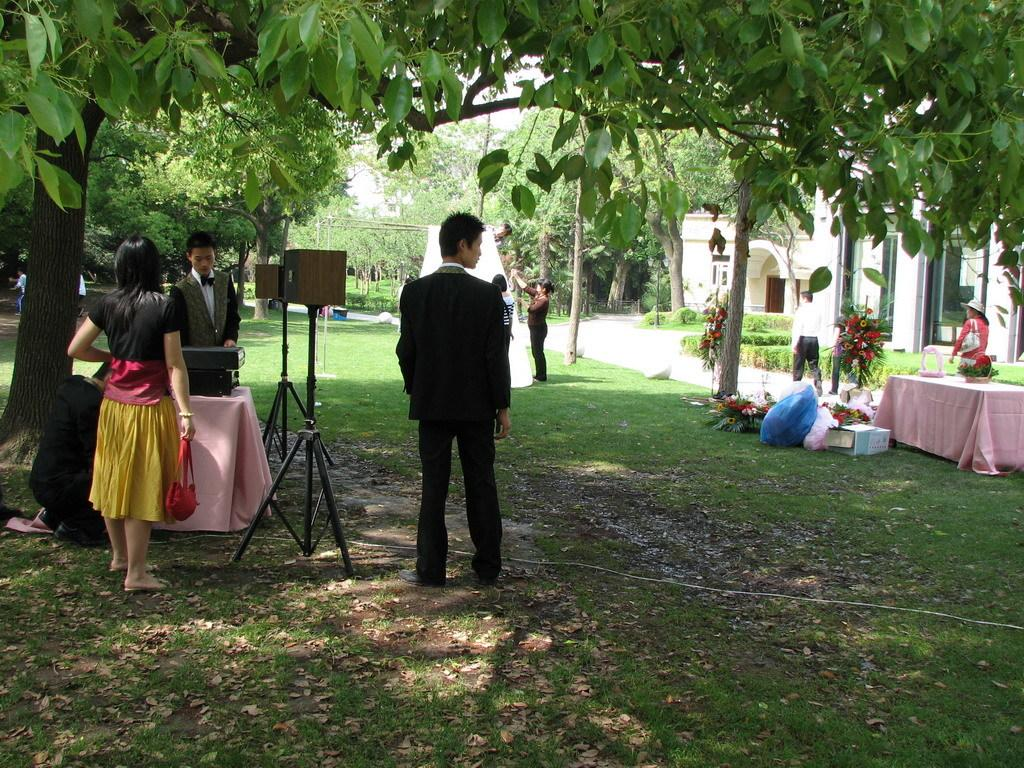Who or what is present in the image? There are people in the image. What object can be seen on the table in the image? There is a flower pot on the table. What type of vegetation is visible in the image? There are trees visible in the image. What can be seen in the background of the image? There is a building in the background of the image. How many deer can be seen in the image? There are no deer present in the image. What type of cough medicine is on the table next to the flower pot? There is no cough medicine present in the image; it only features a flower pot on the table. 